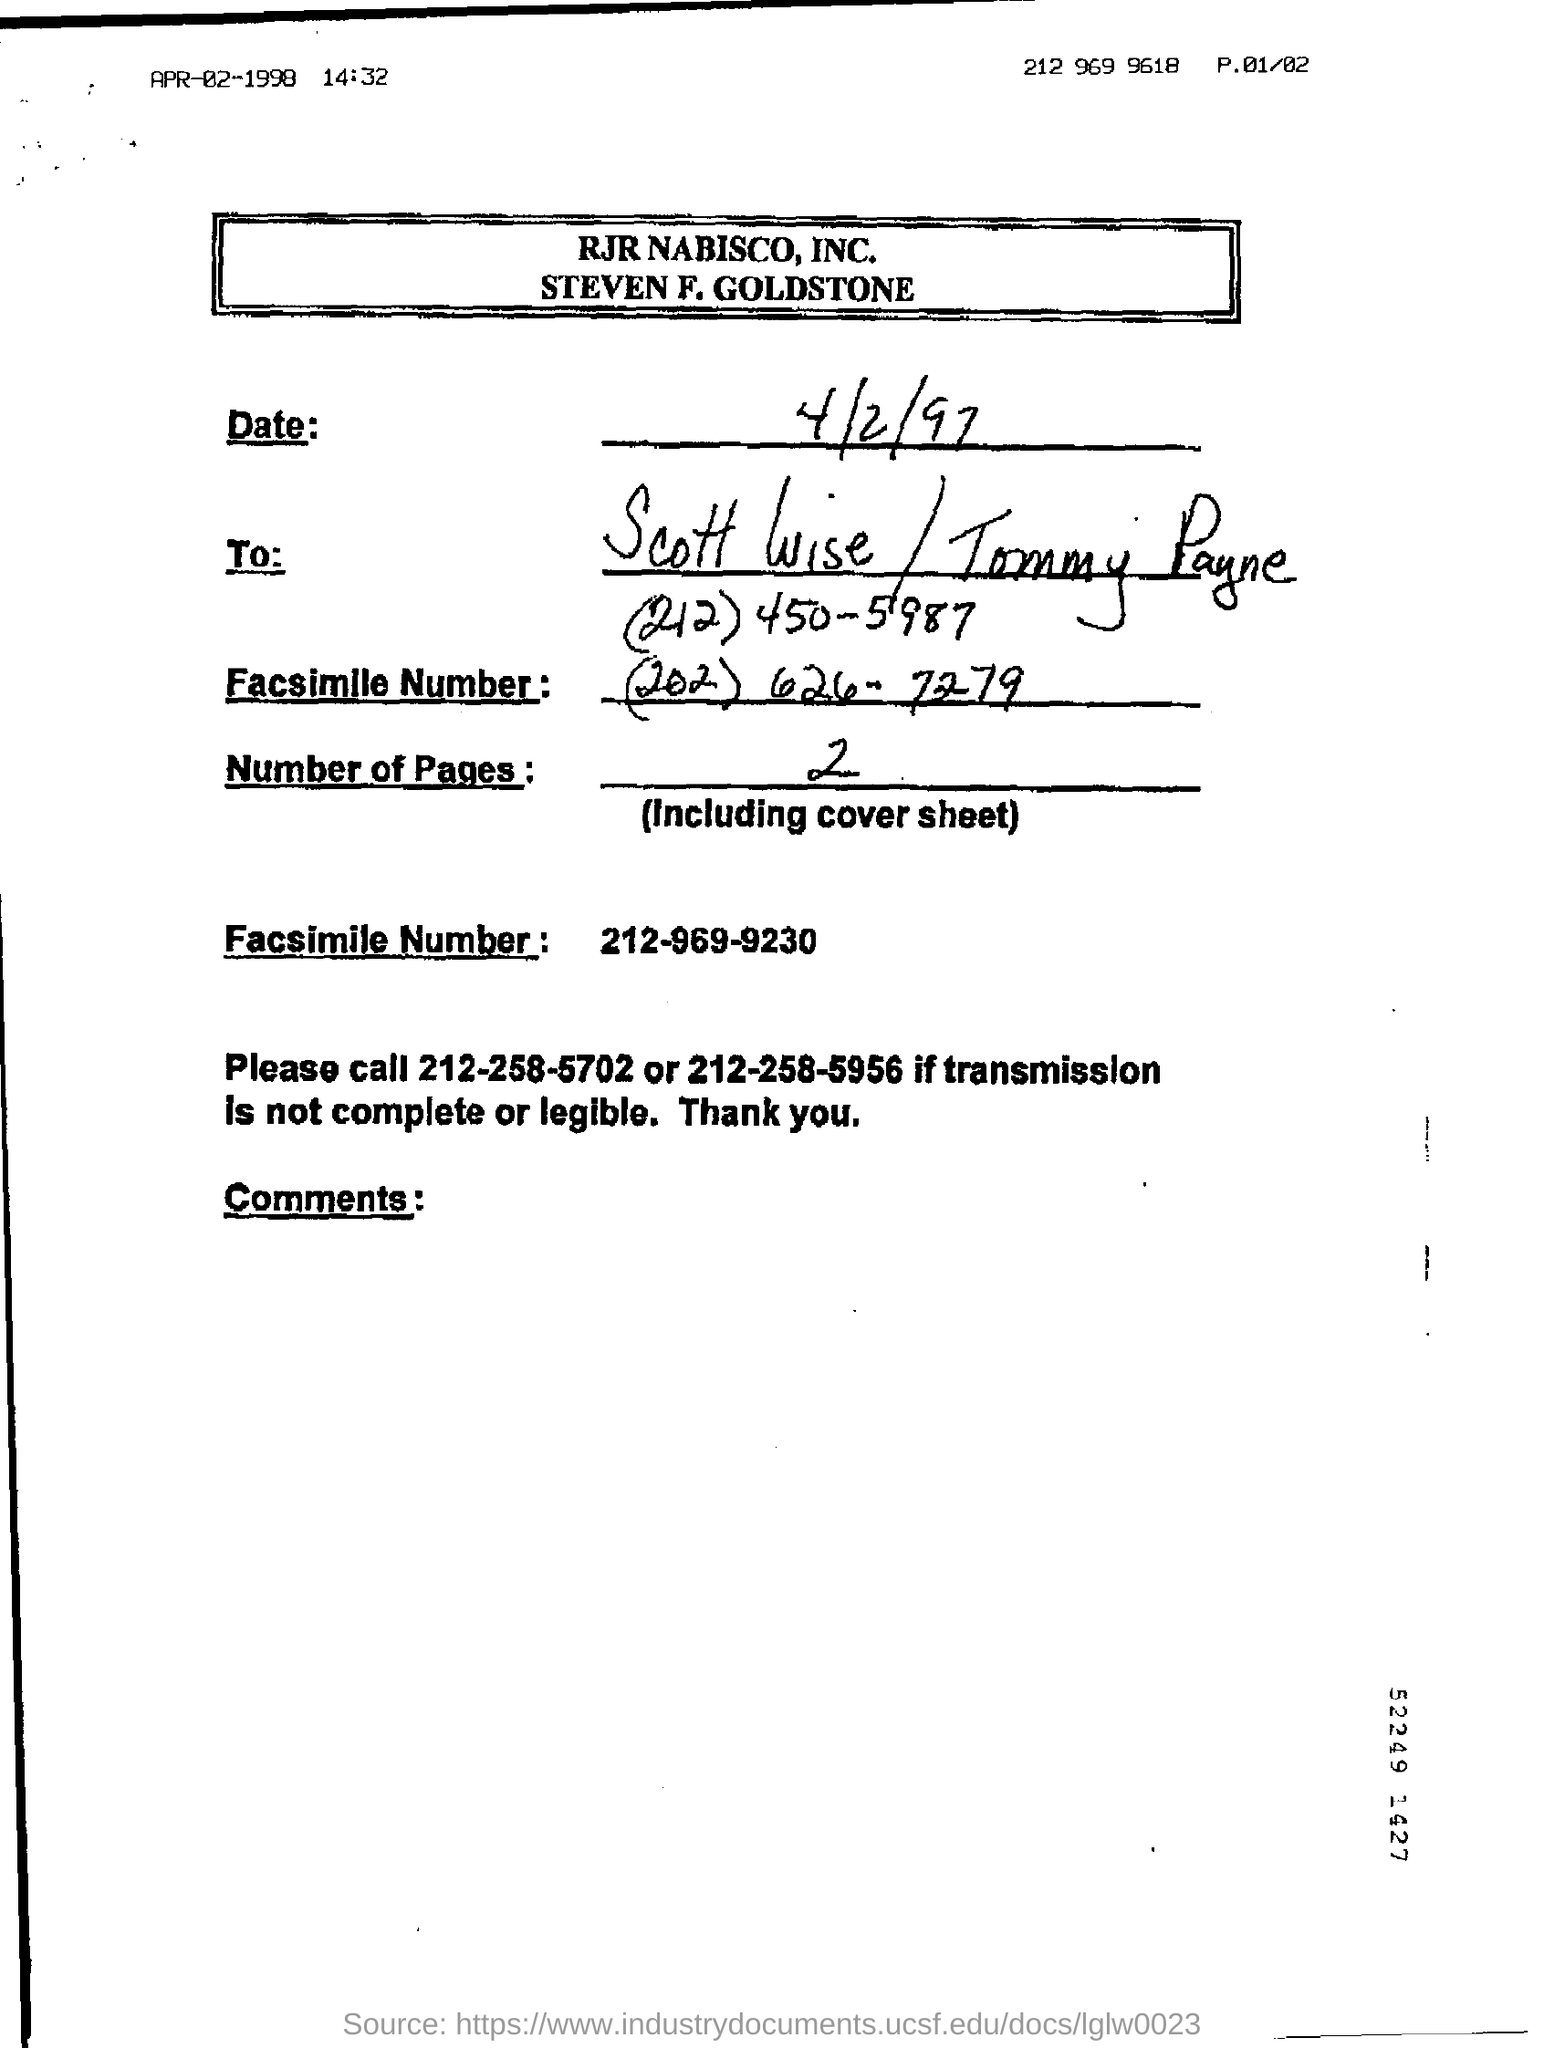What is the date mentioned?
Provide a succinct answer. 4/2/97. What are the Number of Pages?
Provide a succinct answer. 2 pages. What is the number of pages in the fax including cover page?
Provide a succinct answer. 2. 